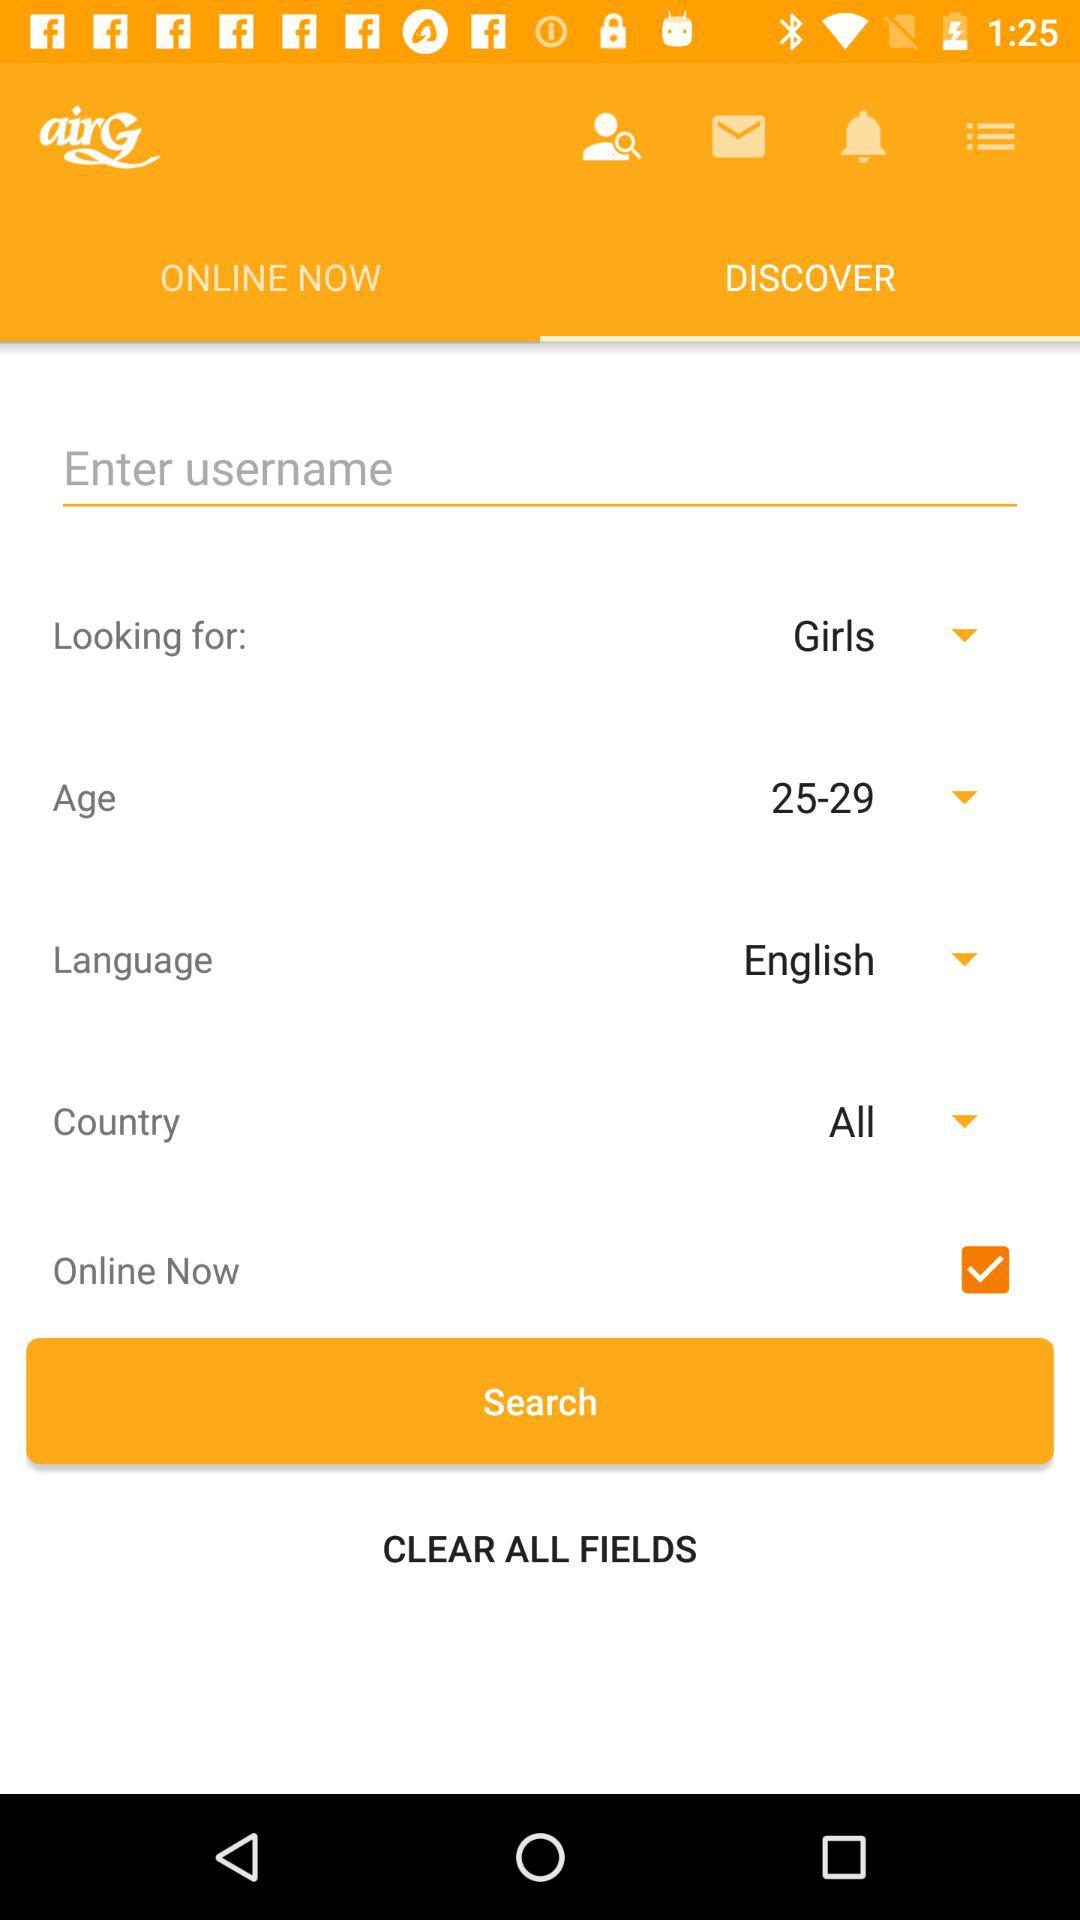How many of the search options are not checkboxes?
Answer the question using a single word or phrase. 4 